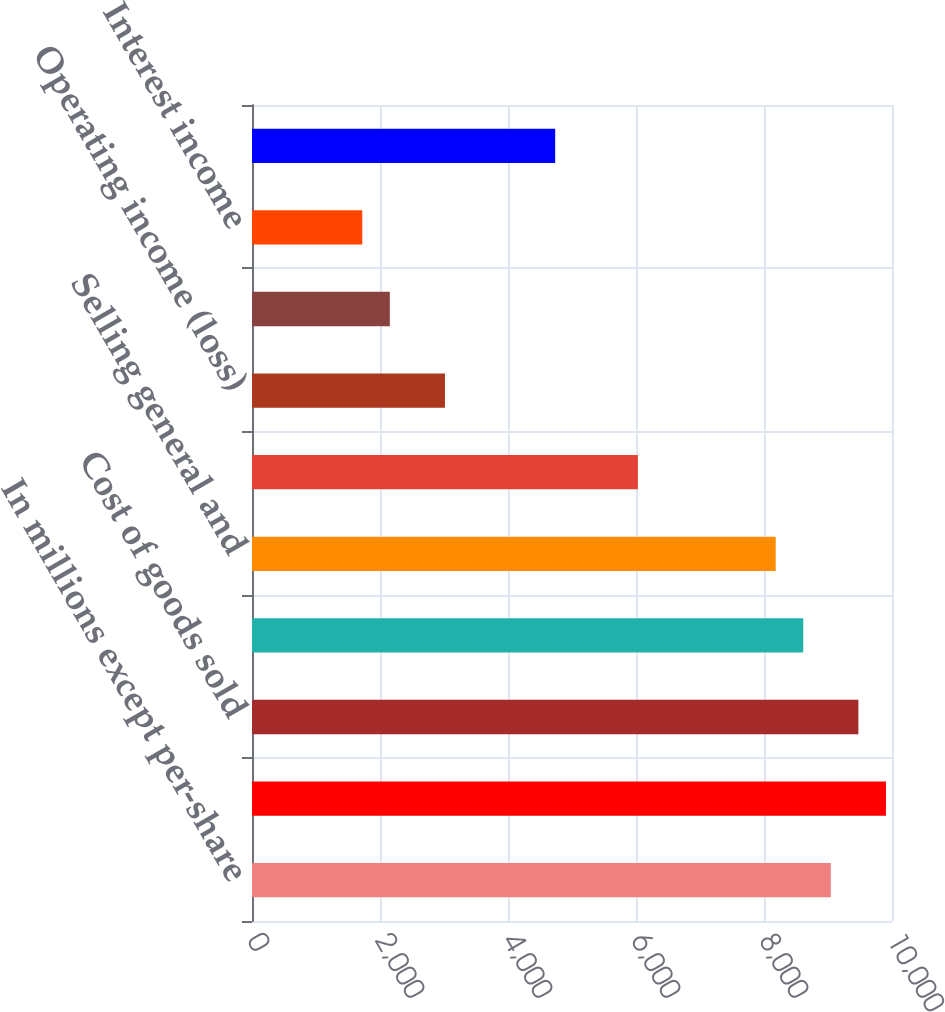Convert chart to OTSL. <chart><loc_0><loc_0><loc_500><loc_500><bar_chart><fcel>In millions except per-share<fcel>Net sales<fcel>Cost of goods sold<fcel>Gross profit<fcel>Selling general and<fcel>Research and development<fcel>Operating income (loss)<fcel>Equity income of<fcel>Interest income<fcel>Interest expense<nl><fcel>9044.06<fcel>9905.38<fcel>9474.72<fcel>8613.4<fcel>8182.74<fcel>6029.44<fcel>3014.82<fcel>2153.5<fcel>1722.84<fcel>4737.46<nl></chart> 